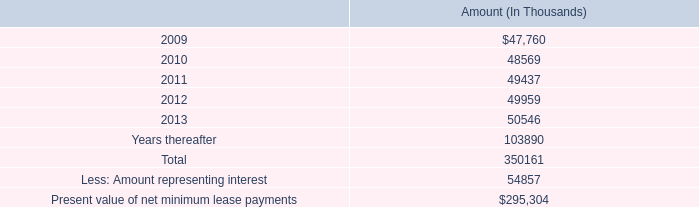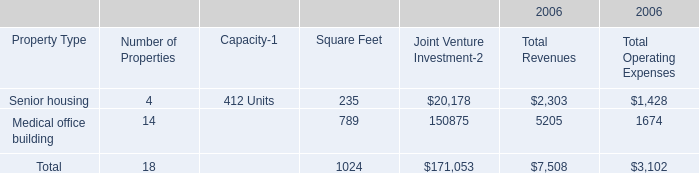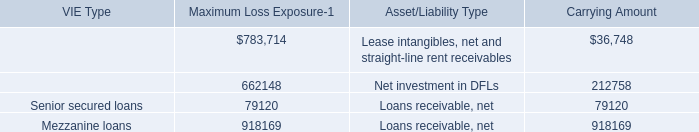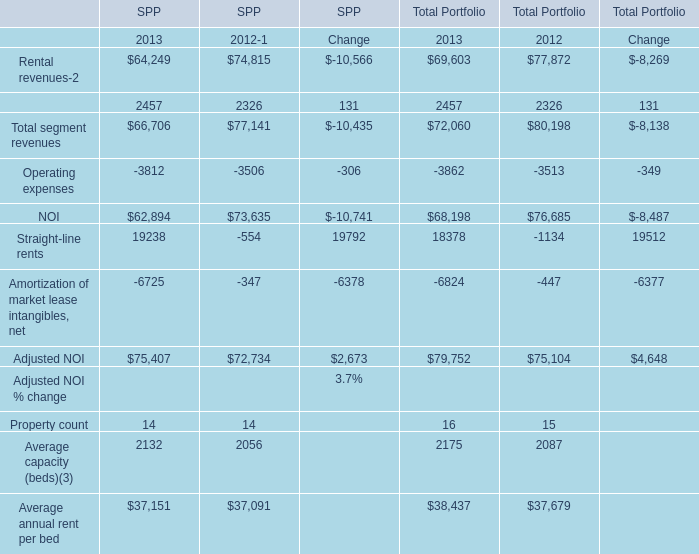what is the highest total amount of NOI for Total Portfolio? 
Answer: 76685. 